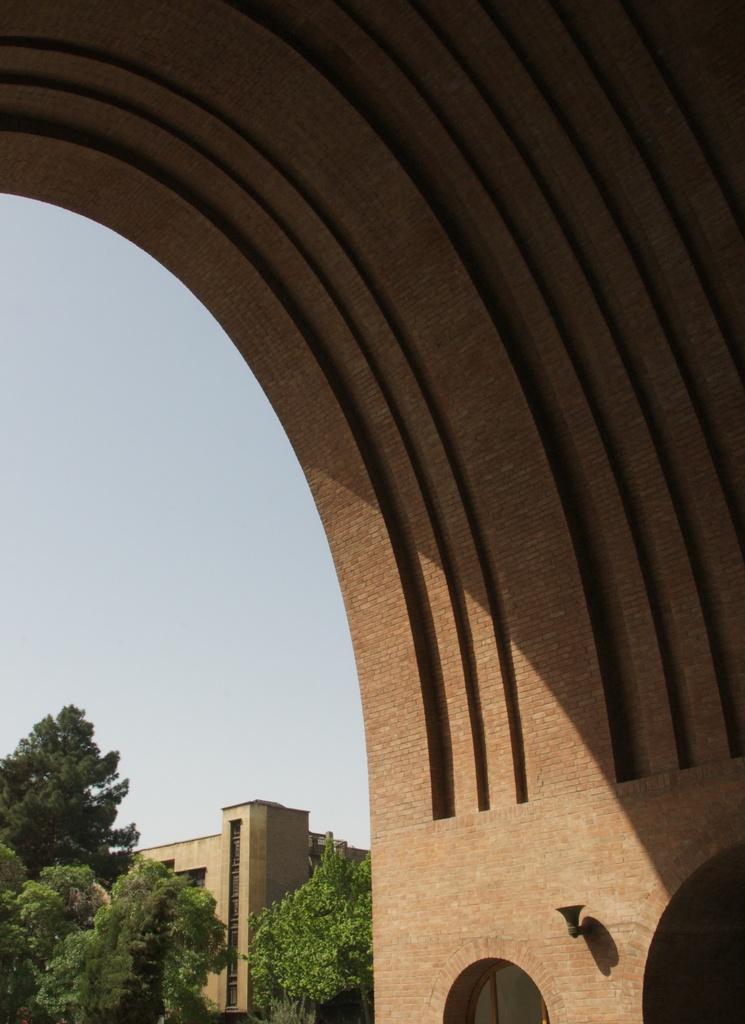How would you summarize this image in a sentence or two? This image consists of an arch made up of bricks. In the background, there is a building along with the trees. 